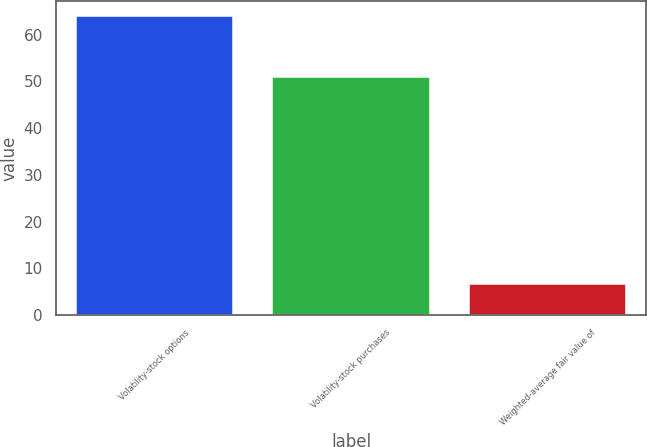<chart> <loc_0><loc_0><loc_500><loc_500><bar_chart><fcel>Volatility-stock options<fcel>Volatility-stock purchases<fcel>Weighted-average fair value of<nl><fcel>64<fcel>51<fcel>6.73<nl></chart> 